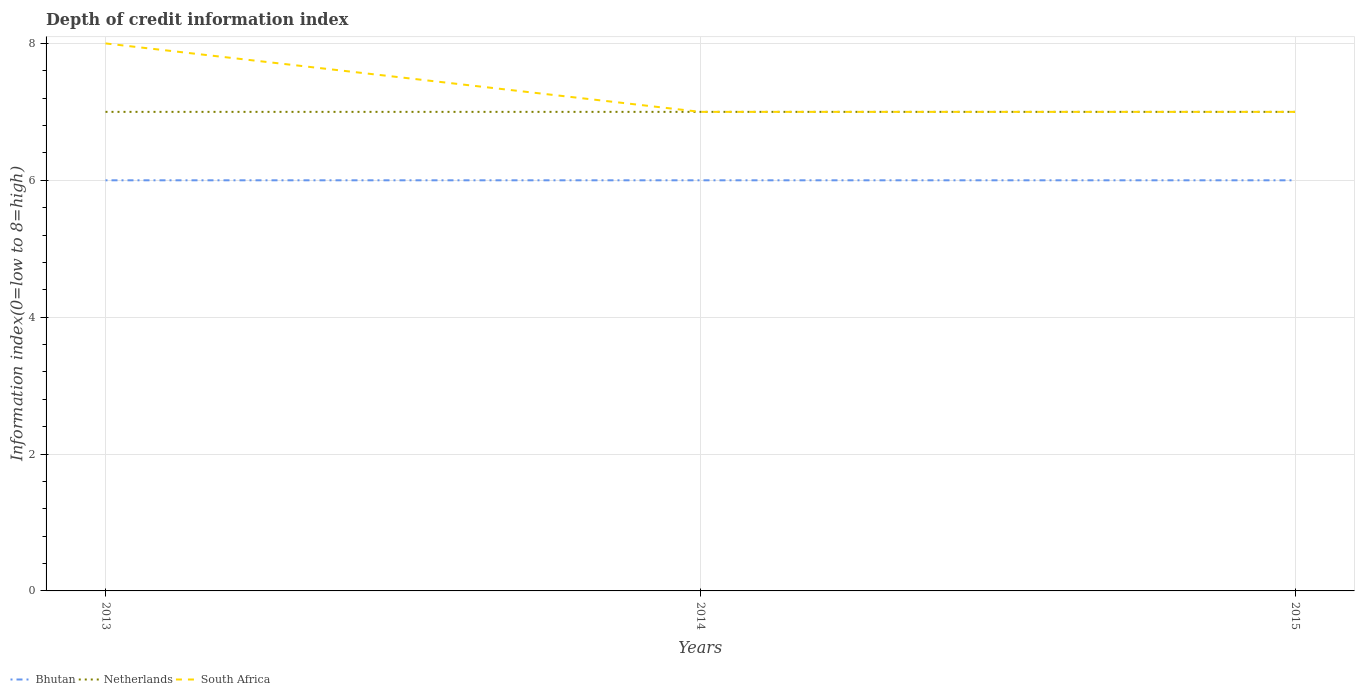Does the line corresponding to South Africa intersect with the line corresponding to Netherlands?
Provide a succinct answer. Yes. Is the number of lines equal to the number of legend labels?
Provide a succinct answer. Yes. Across all years, what is the maximum information index in South Africa?
Keep it short and to the point. 7. In which year was the information index in South Africa maximum?
Keep it short and to the point. 2014. What is the total information index in South Africa in the graph?
Make the answer very short. 1. How many years are there in the graph?
Provide a succinct answer. 3. What is the difference between two consecutive major ticks on the Y-axis?
Your answer should be compact. 2. Does the graph contain any zero values?
Offer a terse response. No. How are the legend labels stacked?
Keep it short and to the point. Horizontal. What is the title of the graph?
Give a very brief answer. Depth of credit information index. What is the label or title of the Y-axis?
Provide a succinct answer. Information index(0=low to 8=high). What is the Information index(0=low to 8=high) of Netherlands in 2013?
Your answer should be very brief. 7. What is the Information index(0=low to 8=high) in South Africa in 2013?
Provide a short and direct response. 8. What is the Information index(0=low to 8=high) of South Africa in 2015?
Your answer should be very brief. 7. Across all years, what is the maximum Information index(0=low to 8=high) of Bhutan?
Ensure brevity in your answer.  6. What is the difference between the Information index(0=low to 8=high) in Bhutan in 2013 and that in 2014?
Provide a succinct answer. 0. What is the difference between the Information index(0=low to 8=high) of South Africa in 2013 and that in 2014?
Offer a very short reply. 1. What is the difference between the Information index(0=low to 8=high) of Bhutan in 2013 and that in 2015?
Offer a terse response. 0. What is the difference between the Information index(0=low to 8=high) in Netherlands in 2013 and that in 2015?
Provide a short and direct response. 0. What is the difference between the Information index(0=low to 8=high) in South Africa in 2013 and that in 2015?
Make the answer very short. 1. What is the difference between the Information index(0=low to 8=high) of Bhutan in 2014 and that in 2015?
Offer a terse response. 0. What is the difference between the Information index(0=low to 8=high) in Netherlands in 2014 and that in 2015?
Provide a succinct answer. 0. What is the difference between the Information index(0=low to 8=high) of South Africa in 2014 and that in 2015?
Make the answer very short. 0. What is the difference between the Information index(0=low to 8=high) in Bhutan in 2013 and the Information index(0=low to 8=high) in Netherlands in 2014?
Offer a very short reply. -1. What is the difference between the Information index(0=low to 8=high) of Bhutan in 2013 and the Information index(0=low to 8=high) of Netherlands in 2015?
Make the answer very short. -1. What is the difference between the Information index(0=low to 8=high) of Bhutan in 2013 and the Information index(0=low to 8=high) of South Africa in 2015?
Your answer should be compact. -1. What is the difference between the Information index(0=low to 8=high) of Netherlands in 2013 and the Information index(0=low to 8=high) of South Africa in 2015?
Your answer should be very brief. 0. What is the difference between the Information index(0=low to 8=high) of Netherlands in 2014 and the Information index(0=low to 8=high) of South Africa in 2015?
Your answer should be compact. 0. What is the average Information index(0=low to 8=high) in Bhutan per year?
Give a very brief answer. 6. What is the average Information index(0=low to 8=high) of Netherlands per year?
Your answer should be compact. 7. What is the average Information index(0=low to 8=high) in South Africa per year?
Provide a short and direct response. 7.33. In the year 2013, what is the difference between the Information index(0=low to 8=high) in Bhutan and Information index(0=low to 8=high) in South Africa?
Provide a short and direct response. -2. In the year 2014, what is the difference between the Information index(0=low to 8=high) in Bhutan and Information index(0=low to 8=high) in Netherlands?
Make the answer very short. -1. In the year 2014, what is the difference between the Information index(0=low to 8=high) in Bhutan and Information index(0=low to 8=high) in South Africa?
Your answer should be compact. -1. In the year 2014, what is the difference between the Information index(0=low to 8=high) of Netherlands and Information index(0=low to 8=high) of South Africa?
Ensure brevity in your answer.  0. In the year 2015, what is the difference between the Information index(0=low to 8=high) of Bhutan and Information index(0=low to 8=high) of Netherlands?
Offer a very short reply. -1. In the year 2015, what is the difference between the Information index(0=low to 8=high) of Bhutan and Information index(0=low to 8=high) of South Africa?
Your answer should be compact. -1. In the year 2015, what is the difference between the Information index(0=low to 8=high) in Netherlands and Information index(0=low to 8=high) in South Africa?
Keep it short and to the point. 0. What is the ratio of the Information index(0=low to 8=high) in Bhutan in 2013 to that in 2014?
Give a very brief answer. 1. What is the ratio of the Information index(0=low to 8=high) of Netherlands in 2014 to that in 2015?
Your response must be concise. 1. What is the ratio of the Information index(0=low to 8=high) in South Africa in 2014 to that in 2015?
Provide a short and direct response. 1. What is the difference between the highest and the second highest Information index(0=low to 8=high) in Bhutan?
Keep it short and to the point. 0. What is the difference between the highest and the lowest Information index(0=low to 8=high) of Bhutan?
Offer a very short reply. 0. 